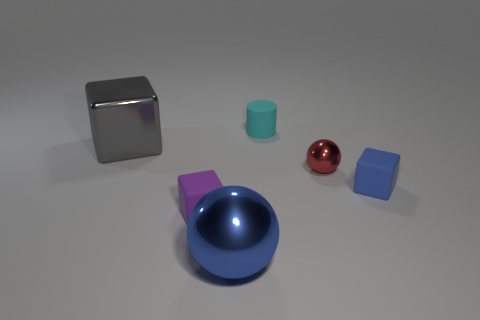There is a object that is the same color as the big metal sphere; what is its shape?
Your answer should be very brief. Cube. What is the color of the shiny thing that is the same size as the rubber cylinder?
Offer a very short reply. Red. How many rubber things are cyan cylinders or balls?
Provide a short and direct response. 1. What number of things are both on the left side of the red object and in front of the tiny red metal ball?
Offer a very short reply. 2. Is there any other thing that is the same shape as the small blue rubber thing?
Your answer should be very brief. Yes. How many other things are there of the same size as the blue block?
Offer a very short reply. 3. Is the size of the metal thing that is behind the tiny metallic ball the same as the matte object right of the small metallic object?
Offer a terse response. No. How many objects are big brown metal objects or objects that are behind the blue cube?
Your answer should be very brief. 3. There is a rubber thing behind the metal cube; how big is it?
Your answer should be very brief. Small. Is the number of objects in front of the red sphere less than the number of big gray cubes that are in front of the purple matte thing?
Offer a terse response. No. 